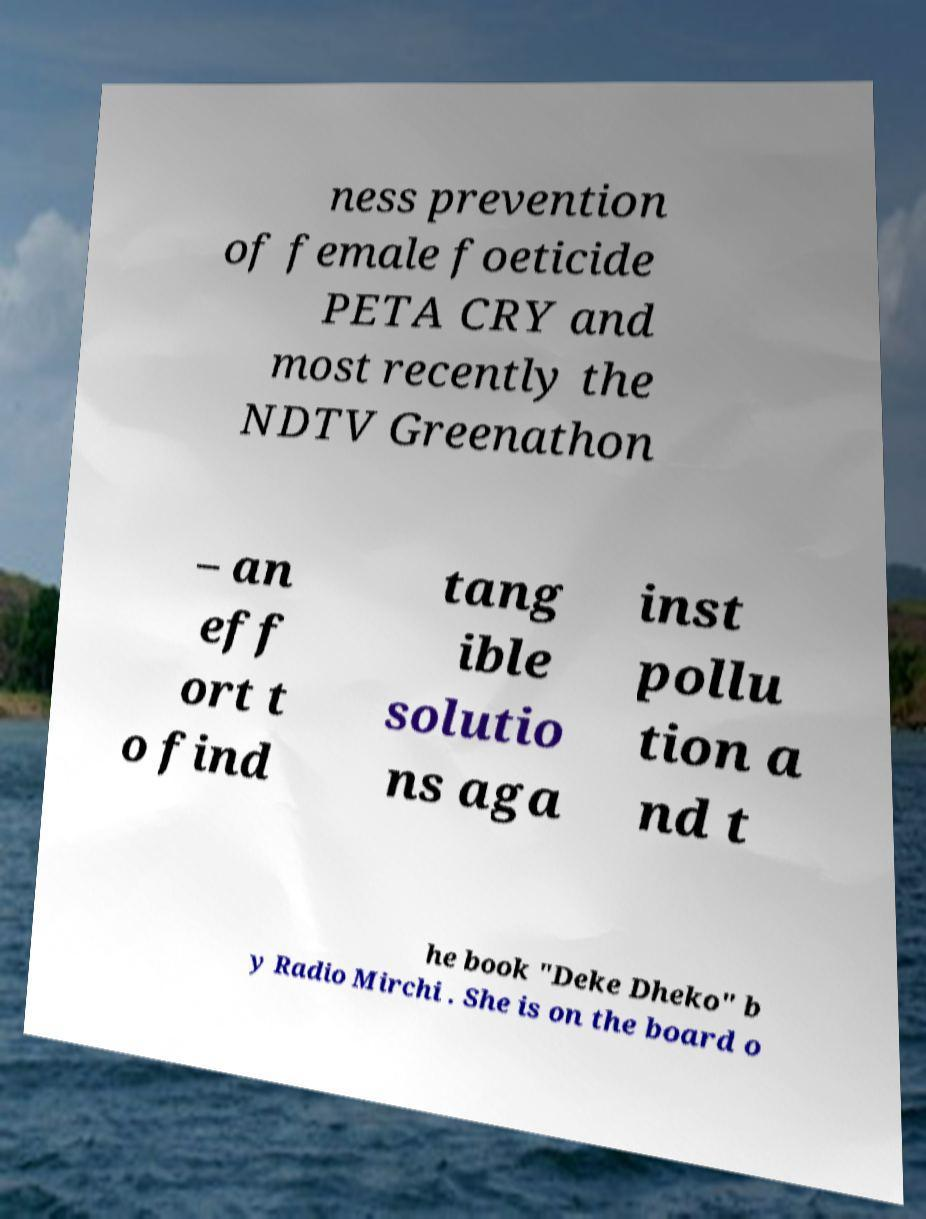What messages or text are displayed in this image? I need them in a readable, typed format. ness prevention of female foeticide PETA CRY and most recently the NDTV Greenathon – an eff ort t o find tang ible solutio ns aga inst pollu tion a nd t he book "Deke Dheko" b y Radio Mirchi . She is on the board o 